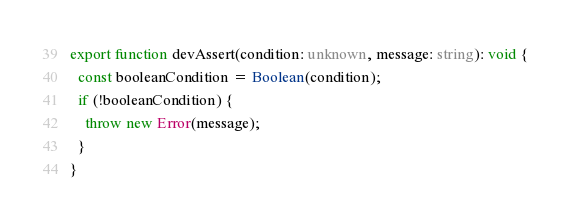Convert code to text. <code><loc_0><loc_0><loc_500><loc_500><_TypeScript_>export function devAssert(condition: unknown, message: string): void {
  const booleanCondition = Boolean(condition);
  if (!booleanCondition) {
    throw new Error(message);
  }
}
</code> 